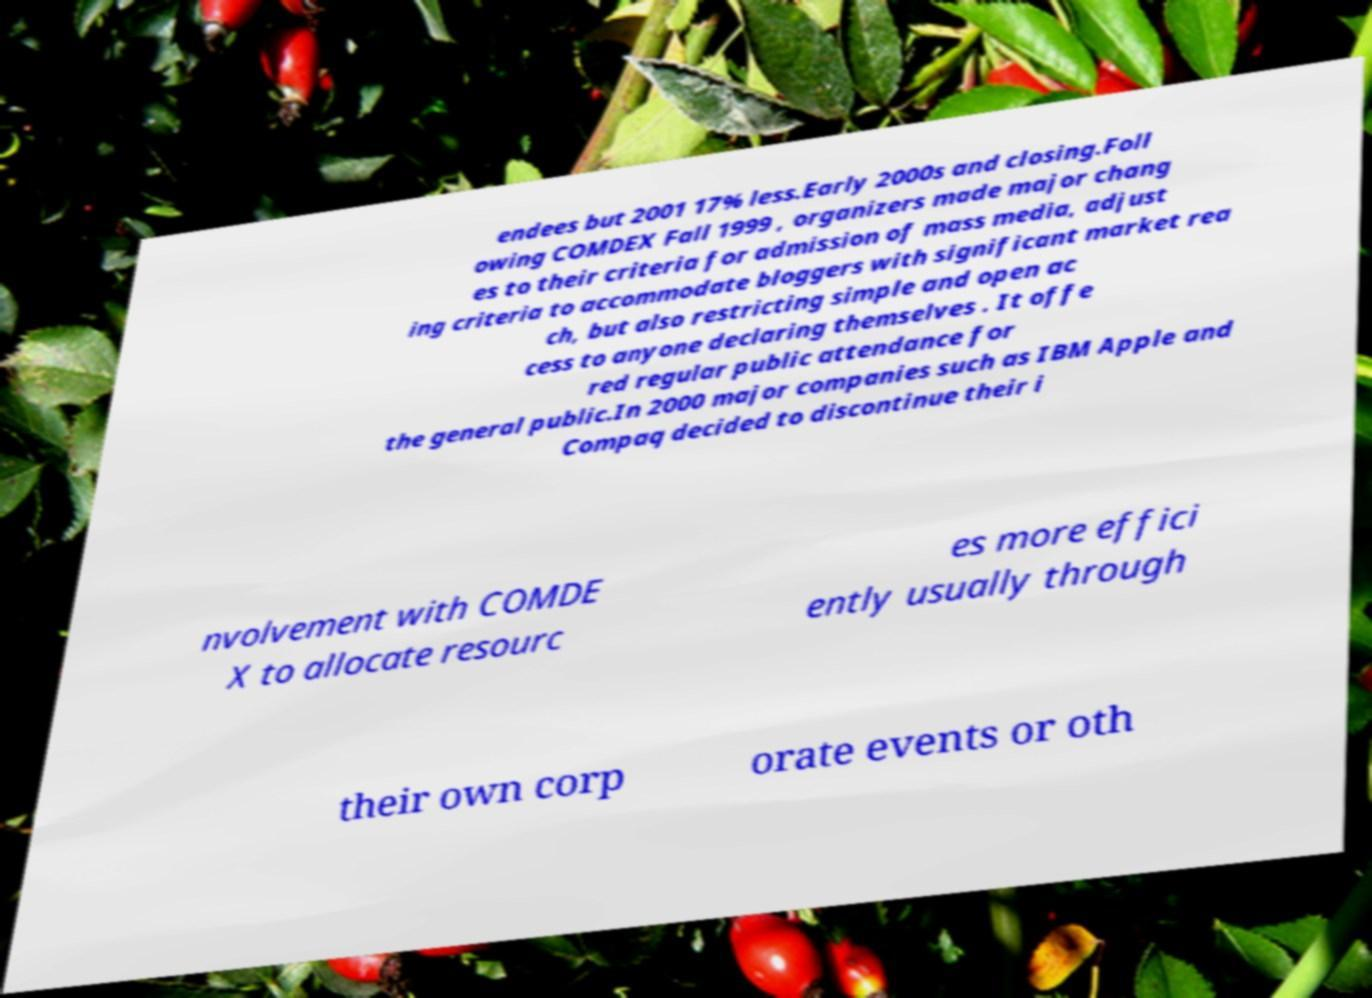Could you extract and type out the text from this image? endees but 2001 17% less.Early 2000s and closing.Foll owing COMDEX Fall 1999 , organizers made major chang es to their criteria for admission of mass media, adjust ing criteria to accommodate bloggers with significant market rea ch, but also restricting simple and open ac cess to anyone declaring themselves . It offe red regular public attendance for the general public.In 2000 major companies such as IBM Apple and Compaq decided to discontinue their i nvolvement with COMDE X to allocate resourc es more effici ently usually through their own corp orate events or oth 